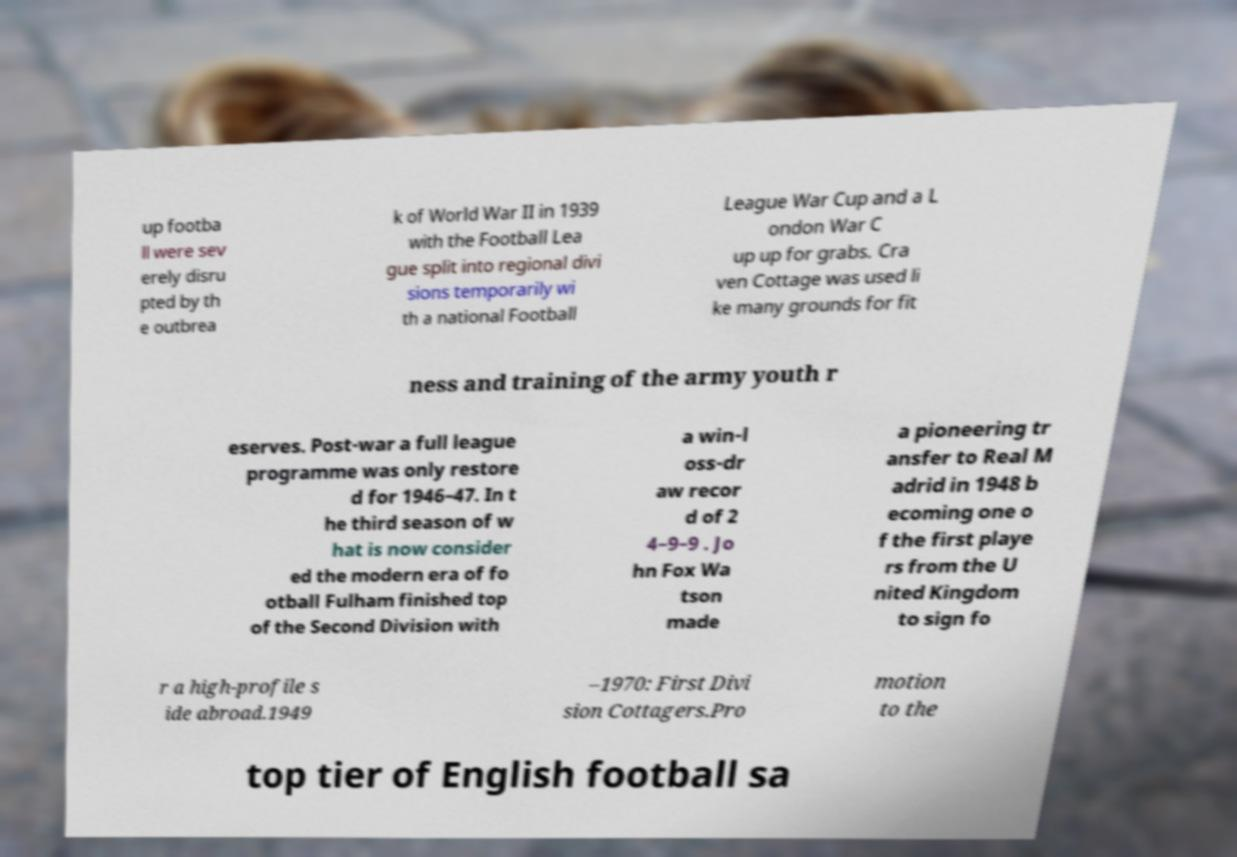Could you extract and type out the text from this image? up footba ll were sev erely disru pted by th e outbrea k of World War II in 1939 with the Football Lea gue split into regional divi sions temporarily wi th a national Football League War Cup and a L ondon War C up up for grabs. Cra ven Cottage was used li ke many grounds for fit ness and training of the army youth r eserves. Post-war a full league programme was only restore d for 1946–47. In t he third season of w hat is now consider ed the modern era of fo otball Fulham finished top of the Second Division with a win-l oss-dr aw recor d of 2 4–9–9 . Jo hn Fox Wa tson made a pioneering tr ansfer to Real M adrid in 1948 b ecoming one o f the first playe rs from the U nited Kingdom to sign fo r a high-profile s ide abroad.1949 –1970: First Divi sion Cottagers.Pro motion to the top tier of English football sa 